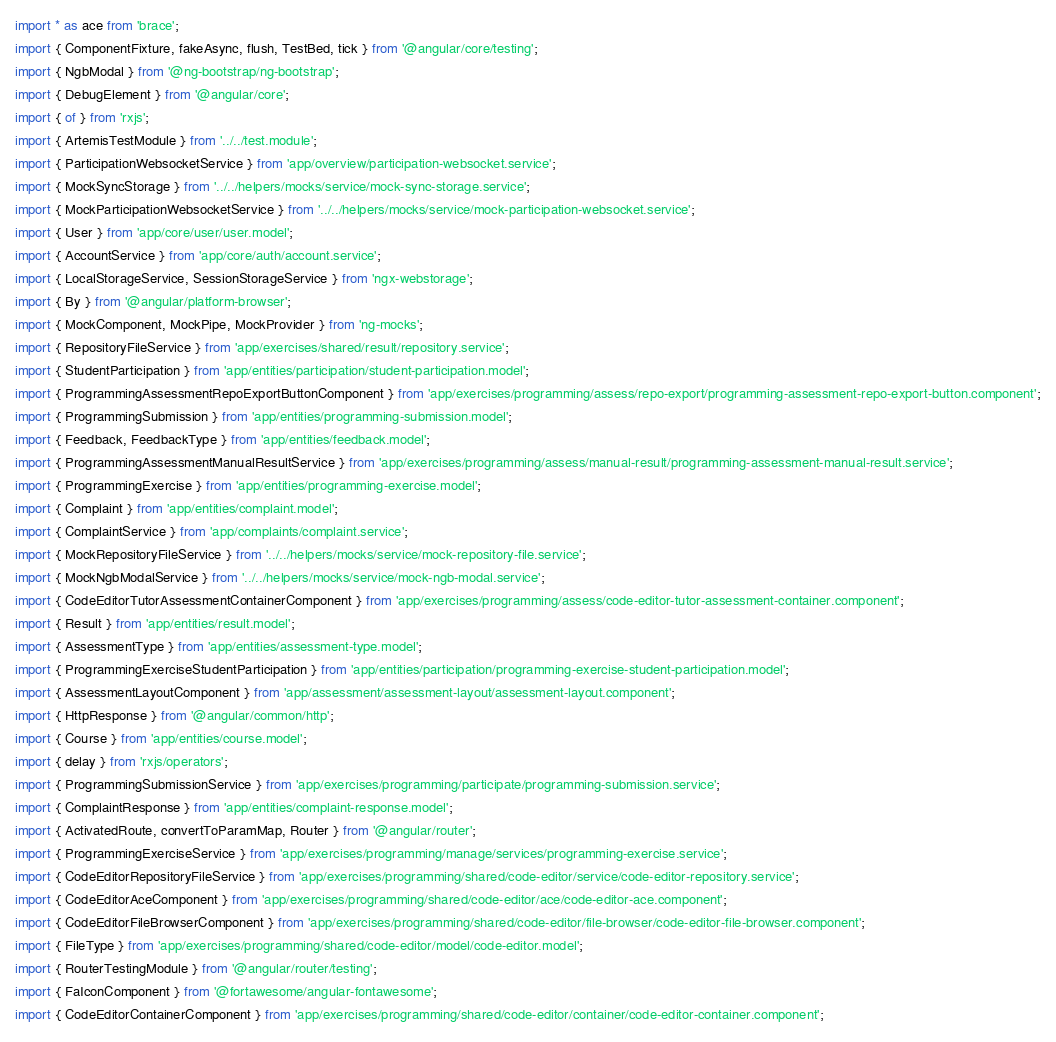Convert code to text. <code><loc_0><loc_0><loc_500><loc_500><_TypeScript_>import * as ace from 'brace';
import { ComponentFixture, fakeAsync, flush, TestBed, tick } from '@angular/core/testing';
import { NgbModal } from '@ng-bootstrap/ng-bootstrap';
import { DebugElement } from '@angular/core';
import { of } from 'rxjs';
import { ArtemisTestModule } from '../../test.module';
import { ParticipationWebsocketService } from 'app/overview/participation-websocket.service';
import { MockSyncStorage } from '../../helpers/mocks/service/mock-sync-storage.service';
import { MockParticipationWebsocketService } from '../../helpers/mocks/service/mock-participation-websocket.service';
import { User } from 'app/core/user/user.model';
import { AccountService } from 'app/core/auth/account.service';
import { LocalStorageService, SessionStorageService } from 'ngx-webstorage';
import { By } from '@angular/platform-browser';
import { MockComponent, MockPipe, MockProvider } from 'ng-mocks';
import { RepositoryFileService } from 'app/exercises/shared/result/repository.service';
import { StudentParticipation } from 'app/entities/participation/student-participation.model';
import { ProgrammingAssessmentRepoExportButtonComponent } from 'app/exercises/programming/assess/repo-export/programming-assessment-repo-export-button.component';
import { ProgrammingSubmission } from 'app/entities/programming-submission.model';
import { Feedback, FeedbackType } from 'app/entities/feedback.model';
import { ProgrammingAssessmentManualResultService } from 'app/exercises/programming/assess/manual-result/programming-assessment-manual-result.service';
import { ProgrammingExercise } from 'app/entities/programming-exercise.model';
import { Complaint } from 'app/entities/complaint.model';
import { ComplaintService } from 'app/complaints/complaint.service';
import { MockRepositoryFileService } from '../../helpers/mocks/service/mock-repository-file.service';
import { MockNgbModalService } from '../../helpers/mocks/service/mock-ngb-modal.service';
import { CodeEditorTutorAssessmentContainerComponent } from 'app/exercises/programming/assess/code-editor-tutor-assessment-container.component';
import { Result } from 'app/entities/result.model';
import { AssessmentType } from 'app/entities/assessment-type.model';
import { ProgrammingExerciseStudentParticipation } from 'app/entities/participation/programming-exercise-student-participation.model';
import { AssessmentLayoutComponent } from 'app/assessment/assessment-layout/assessment-layout.component';
import { HttpResponse } from '@angular/common/http';
import { Course } from 'app/entities/course.model';
import { delay } from 'rxjs/operators';
import { ProgrammingSubmissionService } from 'app/exercises/programming/participate/programming-submission.service';
import { ComplaintResponse } from 'app/entities/complaint-response.model';
import { ActivatedRoute, convertToParamMap, Router } from '@angular/router';
import { ProgrammingExerciseService } from 'app/exercises/programming/manage/services/programming-exercise.service';
import { CodeEditorRepositoryFileService } from 'app/exercises/programming/shared/code-editor/service/code-editor-repository.service';
import { CodeEditorAceComponent } from 'app/exercises/programming/shared/code-editor/ace/code-editor-ace.component';
import { CodeEditorFileBrowserComponent } from 'app/exercises/programming/shared/code-editor/file-browser/code-editor-file-browser.component';
import { FileType } from 'app/exercises/programming/shared/code-editor/model/code-editor.model';
import { RouterTestingModule } from '@angular/router/testing';
import { FaIconComponent } from '@fortawesome/angular-fontawesome';
import { CodeEditorContainerComponent } from 'app/exercises/programming/shared/code-editor/container/code-editor-container.component';</code> 